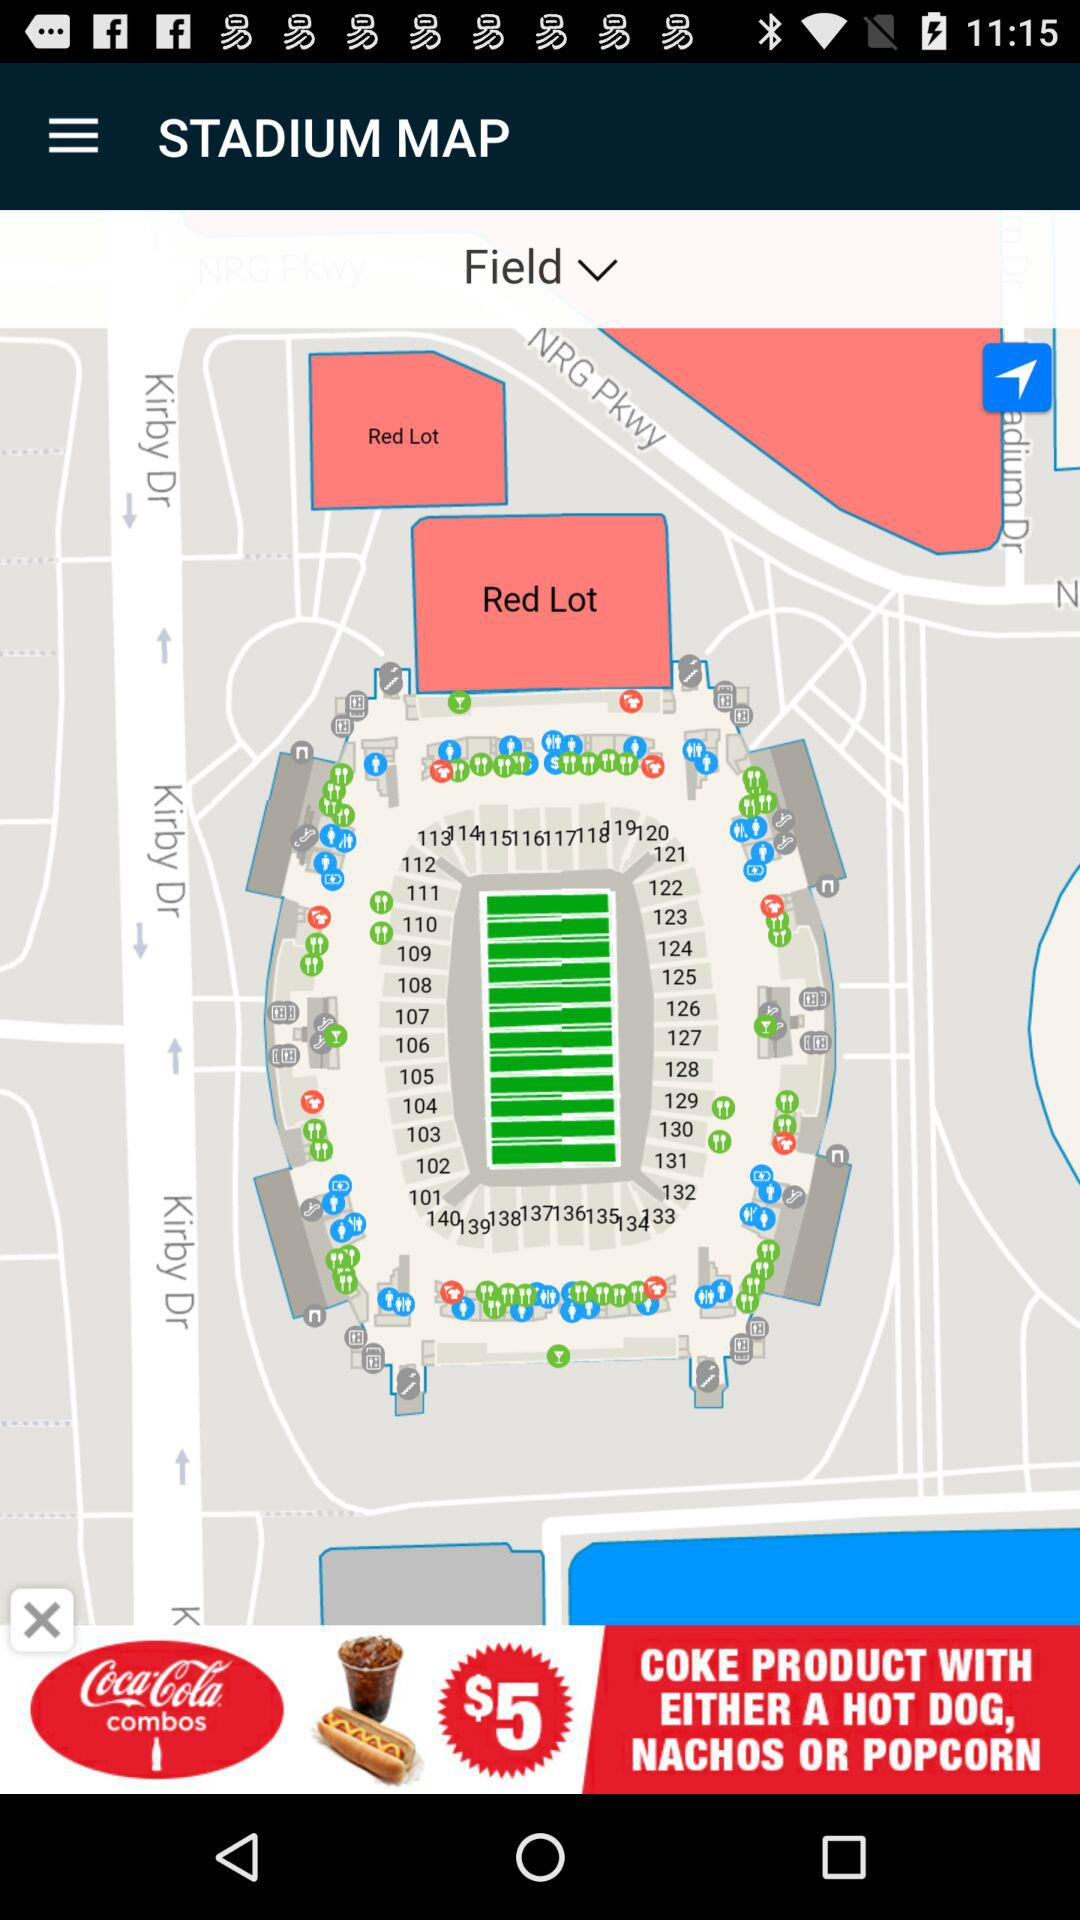How many different food options are there?
Answer the question using a single word or phrase. 3 